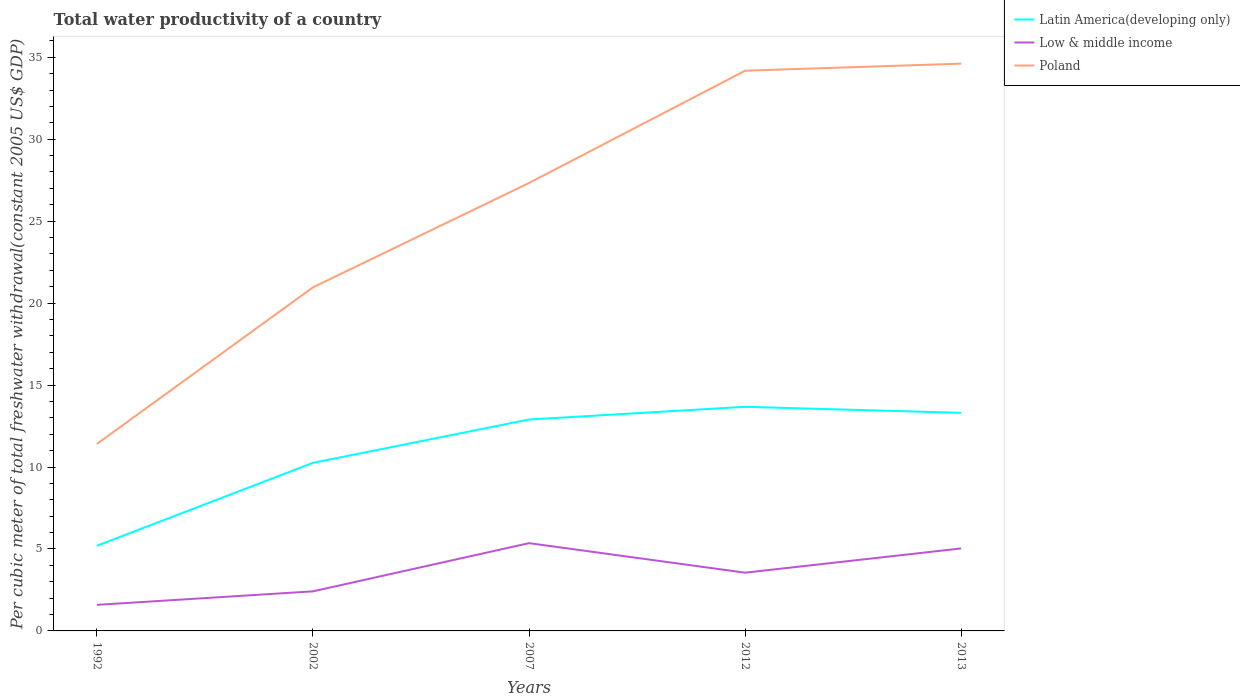How many different coloured lines are there?
Provide a short and direct response. 3. Does the line corresponding to Low & middle income intersect with the line corresponding to Poland?
Ensure brevity in your answer.  No. Across all years, what is the maximum total water productivity in Latin America(developing only)?
Offer a terse response. 5.19. In which year was the total water productivity in Low & middle income maximum?
Your answer should be compact. 1992. What is the total total water productivity in Poland in the graph?
Ensure brevity in your answer.  -9.55. What is the difference between the highest and the second highest total water productivity in Latin America(developing only)?
Give a very brief answer. 8.48. Is the total water productivity in Latin America(developing only) strictly greater than the total water productivity in Poland over the years?
Provide a succinct answer. Yes. How are the legend labels stacked?
Ensure brevity in your answer.  Vertical. What is the title of the graph?
Offer a terse response. Total water productivity of a country. What is the label or title of the X-axis?
Your response must be concise. Years. What is the label or title of the Y-axis?
Keep it short and to the point. Per cubic meter of total freshwater withdrawal(constant 2005 US$ GDP). What is the Per cubic meter of total freshwater withdrawal(constant 2005 US$ GDP) in Latin America(developing only) in 1992?
Your answer should be very brief. 5.19. What is the Per cubic meter of total freshwater withdrawal(constant 2005 US$ GDP) of Low & middle income in 1992?
Ensure brevity in your answer.  1.59. What is the Per cubic meter of total freshwater withdrawal(constant 2005 US$ GDP) of Poland in 1992?
Provide a short and direct response. 11.41. What is the Per cubic meter of total freshwater withdrawal(constant 2005 US$ GDP) in Latin America(developing only) in 2002?
Ensure brevity in your answer.  10.26. What is the Per cubic meter of total freshwater withdrawal(constant 2005 US$ GDP) in Low & middle income in 2002?
Give a very brief answer. 2.41. What is the Per cubic meter of total freshwater withdrawal(constant 2005 US$ GDP) of Poland in 2002?
Provide a short and direct response. 20.96. What is the Per cubic meter of total freshwater withdrawal(constant 2005 US$ GDP) of Latin America(developing only) in 2007?
Ensure brevity in your answer.  12.9. What is the Per cubic meter of total freshwater withdrawal(constant 2005 US$ GDP) in Low & middle income in 2007?
Your answer should be very brief. 5.35. What is the Per cubic meter of total freshwater withdrawal(constant 2005 US$ GDP) of Poland in 2007?
Keep it short and to the point. 27.33. What is the Per cubic meter of total freshwater withdrawal(constant 2005 US$ GDP) of Latin America(developing only) in 2012?
Your answer should be very brief. 13.67. What is the Per cubic meter of total freshwater withdrawal(constant 2005 US$ GDP) of Low & middle income in 2012?
Offer a very short reply. 3.55. What is the Per cubic meter of total freshwater withdrawal(constant 2005 US$ GDP) of Poland in 2012?
Keep it short and to the point. 34.18. What is the Per cubic meter of total freshwater withdrawal(constant 2005 US$ GDP) in Latin America(developing only) in 2013?
Your response must be concise. 13.31. What is the Per cubic meter of total freshwater withdrawal(constant 2005 US$ GDP) of Low & middle income in 2013?
Provide a succinct answer. 5.03. What is the Per cubic meter of total freshwater withdrawal(constant 2005 US$ GDP) of Poland in 2013?
Your response must be concise. 34.61. Across all years, what is the maximum Per cubic meter of total freshwater withdrawal(constant 2005 US$ GDP) of Latin America(developing only)?
Offer a very short reply. 13.67. Across all years, what is the maximum Per cubic meter of total freshwater withdrawal(constant 2005 US$ GDP) in Low & middle income?
Your answer should be compact. 5.35. Across all years, what is the maximum Per cubic meter of total freshwater withdrawal(constant 2005 US$ GDP) in Poland?
Your response must be concise. 34.61. Across all years, what is the minimum Per cubic meter of total freshwater withdrawal(constant 2005 US$ GDP) of Latin America(developing only)?
Make the answer very short. 5.19. Across all years, what is the minimum Per cubic meter of total freshwater withdrawal(constant 2005 US$ GDP) in Low & middle income?
Offer a terse response. 1.59. Across all years, what is the minimum Per cubic meter of total freshwater withdrawal(constant 2005 US$ GDP) in Poland?
Make the answer very short. 11.41. What is the total Per cubic meter of total freshwater withdrawal(constant 2005 US$ GDP) of Latin America(developing only) in the graph?
Provide a short and direct response. 55.33. What is the total Per cubic meter of total freshwater withdrawal(constant 2005 US$ GDP) of Low & middle income in the graph?
Keep it short and to the point. 17.95. What is the total Per cubic meter of total freshwater withdrawal(constant 2005 US$ GDP) in Poland in the graph?
Provide a succinct answer. 128.49. What is the difference between the Per cubic meter of total freshwater withdrawal(constant 2005 US$ GDP) of Latin America(developing only) in 1992 and that in 2002?
Your response must be concise. -5.06. What is the difference between the Per cubic meter of total freshwater withdrawal(constant 2005 US$ GDP) in Low & middle income in 1992 and that in 2002?
Provide a succinct answer. -0.82. What is the difference between the Per cubic meter of total freshwater withdrawal(constant 2005 US$ GDP) of Poland in 1992 and that in 2002?
Provide a short and direct response. -9.55. What is the difference between the Per cubic meter of total freshwater withdrawal(constant 2005 US$ GDP) in Latin America(developing only) in 1992 and that in 2007?
Your answer should be compact. -7.7. What is the difference between the Per cubic meter of total freshwater withdrawal(constant 2005 US$ GDP) of Low & middle income in 1992 and that in 2007?
Keep it short and to the point. -3.76. What is the difference between the Per cubic meter of total freshwater withdrawal(constant 2005 US$ GDP) of Poland in 1992 and that in 2007?
Offer a very short reply. -15.92. What is the difference between the Per cubic meter of total freshwater withdrawal(constant 2005 US$ GDP) of Latin America(developing only) in 1992 and that in 2012?
Your response must be concise. -8.48. What is the difference between the Per cubic meter of total freshwater withdrawal(constant 2005 US$ GDP) of Low & middle income in 1992 and that in 2012?
Your answer should be very brief. -1.96. What is the difference between the Per cubic meter of total freshwater withdrawal(constant 2005 US$ GDP) of Poland in 1992 and that in 2012?
Your answer should be compact. -22.77. What is the difference between the Per cubic meter of total freshwater withdrawal(constant 2005 US$ GDP) of Latin America(developing only) in 1992 and that in 2013?
Offer a terse response. -8.11. What is the difference between the Per cubic meter of total freshwater withdrawal(constant 2005 US$ GDP) of Low & middle income in 1992 and that in 2013?
Make the answer very short. -3.44. What is the difference between the Per cubic meter of total freshwater withdrawal(constant 2005 US$ GDP) of Poland in 1992 and that in 2013?
Your answer should be very brief. -23.2. What is the difference between the Per cubic meter of total freshwater withdrawal(constant 2005 US$ GDP) in Latin America(developing only) in 2002 and that in 2007?
Provide a short and direct response. -2.64. What is the difference between the Per cubic meter of total freshwater withdrawal(constant 2005 US$ GDP) in Low & middle income in 2002 and that in 2007?
Make the answer very short. -2.94. What is the difference between the Per cubic meter of total freshwater withdrawal(constant 2005 US$ GDP) of Poland in 2002 and that in 2007?
Provide a succinct answer. -6.37. What is the difference between the Per cubic meter of total freshwater withdrawal(constant 2005 US$ GDP) in Latin America(developing only) in 2002 and that in 2012?
Give a very brief answer. -3.42. What is the difference between the Per cubic meter of total freshwater withdrawal(constant 2005 US$ GDP) of Low & middle income in 2002 and that in 2012?
Your answer should be compact. -1.14. What is the difference between the Per cubic meter of total freshwater withdrawal(constant 2005 US$ GDP) in Poland in 2002 and that in 2012?
Offer a very short reply. -13.21. What is the difference between the Per cubic meter of total freshwater withdrawal(constant 2005 US$ GDP) in Latin America(developing only) in 2002 and that in 2013?
Keep it short and to the point. -3.05. What is the difference between the Per cubic meter of total freshwater withdrawal(constant 2005 US$ GDP) in Low & middle income in 2002 and that in 2013?
Offer a very short reply. -2.62. What is the difference between the Per cubic meter of total freshwater withdrawal(constant 2005 US$ GDP) of Poland in 2002 and that in 2013?
Keep it short and to the point. -13.65. What is the difference between the Per cubic meter of total freshwater withdrawal(constant 2005 US$ GDP) in Latin America(developing only) in 2007 and that in 2012?
Make the answer very short. -0.77. What is the difference between the Per cubic meter of total freshwater withdrawal(constant 2005 US$ GDP) of Low & middle income in 2007 and that in 2012?
Keep it short and to the point. 1.8. What is the difference between the Per cubic meter of total freshwater withdrawal(constant 2005 US$ GDP) in Poland in 2007 and that in 2012?
Keep it short and to the point. -6.85. What is the difference between the Per cubic meter of total freshwater withdrawal(constant 2005 US$ GDP) in Latin America(developing only) in 2007 and that in 2013?
Offer a terse response. -0.41. What is the difference between the Per cubic meter of total freshwater withdrawal(constant 2005 US$ GDP) of Low & middle income in 2007 and that in 2013?
Offer a terse response. 0.32. What is the difference between the Per cubic meter of total freshwater withdrawal(constant 2005 US$ GDP) in Poland in 2007 and that in 2013?
Make the answer very short. -7.28. What is the difference between the Per cubic meter of total freshwater withdrawal(constant 2005 US$ GDP) of Latin America(developing only) in 2012 and that in 2013?
Offer a terse response. 0.37. What is the difference between the Per cubic meter of total freshwater withdrawal(constant 2005 US$ GDP) of Low & middle income in 2012 and that in 2013?
Your response must be concise. -1.48. What is the difference between the Per cubic meter of total freshwater withdrawal(constant 2005 US$ GDP) of Poland in 2012 and that in 2013?
Keep it short and to the point. -0.43. What is the difference between the Per cubic meter of total freshwater withdrawal(constant 2005 US$ GDP) of Latin America(developing only) in 1992 and the Per cubic meter of total freshwater withdrawal(constant 2005 US$ GDP) of Low & middle income in 2002?
Your answer should be compact. 2.78. What is the difference between the Per cubic meter of total freshwater withdrawal(constant 2005 US$ GDP) of Latin America(developing only) in 1992 and the Per cubic meter of total freshwater withdrawal(constant 2005 US$ GDP) of Poland in 2002?
Keep it short and to the point. -15.77. What is the difference between the Per cubic meter of total freshwater withdrawal(constant 2005 US$ GDP) of Low & middle income in 1992 and the Per cubic meter of total freshwater withdrawal(constant 2005 US$ GDP) of Poland in 2002?
Provide a short and direct response. -19.37. What is the difference between the Per cubic meter of total freshwater withdrawal(constant 2005 US$ GDP) in Latin America(developing only) in 1992 and the Per cubic meter of total freshwater withdrawal(constant 2005 US$ GDP) in Low & middle income in 2007?
Give a very brief answer. -0.16. What is the difference between the Per cubic meter of total freshwater withdrawal(constant 2005 US$ GDP) in Latin America(developing only) in 1992 and the Per cubic meter of total freshwater withdrawal(constant 2005 US$ GDP) in Poland in 2007?
Provide a short and direct response. -22.13. What is the difference between the Per cubic meter of total freshwater withdrawal(constant 2005 US$ GDP) in Low & middle income in 1992 and the Per cubic meter of total freshwater withdrawal(constant 2005 US$ GDP) in Poland in 2007?
Ensure brevity in your answer.  -25.74. What is the difference between the Per cubic meter of total freshwater withdrawal(constant 2005 US$ GDP) in Latin America(developing only) in 1992 and the Per cubic meter of total freshwater withdrawal(constant 2005 US$ GDP) in Low & middle income in 2012?
Provide a short and direct response. 1.64. What is the difference between the Per cubic meter of total freshwater withdrawal(constant 2005 US$ GDP) of Latin America(developing only) in 1992 and the Per cubic meter of total freshwater withdrawal(constant 2005 US$ GDP) of Poland in 2012?
Offer a very short reply. -28.98. What is the difference between the Per cubic meter of total freshwater withdrawal(constant 2005 US$ GDP) in Low & middle income in 1992 and the Per cubic meter of total freshwater withdrawal(constant 2005 US$ GDP) in Poland in 2012?
Provide a short and direct response. -32.59. What is the difference between the Per cubic meter of total freshwater withdrawal(constant 2005 US$ GDP) in Latin America(developing only) in 1992 and the Per cubic meter of total freshwater withdrawal(constant 2005 US$ GDP) in Low & middle income in 2013?
Your answer should be compact. 0.16. What is the difference between the Per cubic meter of total freshwater withdrawal(constant 2005 US$ GDP) in Latin America(developing only) in 1992 and the Per cubic meter of total freshwater withdrawal(constant 2005 US$ GDP) in Poland in 2013?
Your answer should be compact. -29.42. What is the difference between the Per cubic meter of total freshwater withdrawal(constant 2005 US$ GDP) of Low & middle income in 1992 and the Per cubic meter of total freshwater withdrawal(constant 2005 US$ GDP) of Poland in 2013?
Ensure brevity in your answer.  -33.02. What is the difference between the Per cubic meter of total freshwater withdrawal(constant 2005 US$ GDP) of Latin America(developing only) in 2002 and the Per cubic meter of total freshwater withdrawal(constant 2005 US$ GDP) of Low & middle income in 2007?
Make the answer very short. 4.9. What is the difference between the Per cubic meter of total freshwater withdrawal(constant 2005 US$ GDP) in Latin America(developing only) in 2002 and the Per cubic meter of total freshwater withdrawal(constant 2005 US$ GDP) in Poland in 2007?
Make the answer very short. -17.07. What is the difference between the Per cubic meter of total freshwater withdrawal(constant 2005 US$ GDP) in Low & middle income in 2002 and the Per cubic meter of total freshwater withdrawal(constant 2005 US$ GDP) in Poland in 2007?
Ensure brevity in your answer.  -24.92. What is the difference between the Per cubic meter of total freshwater withdrawal(constant 2005 US$ GDP) of Latin America(developing only) in 2002 and the Per cubic meter of total freshwater withdrawal(constant 2005 US$ GDP) of Low & middle income in 2012?
Give a very brief answer. 6.7. What is the difference between the Per cubic meter of total freshwater withdrawal(constant 2005 US$ GDP) in Latin America(developing only) in 2002 and the Per cubic meter of total freshwater withdrawal(constant 2005 US$ GDP) in Poland in 2012?
Offer a very short reply. -23.92. What is the difference between the Per cubic meter of total freshwater withdrawal(constant 2005 US$ GDP) of Low & middle income in 2002 and the Per cubic meter of total freshwater withdrawal(constant 2005 US$ GDP) of Poland in 2012?
Offer a terse response. -31.76. What is the difference between the Per cubic meter of total freshwater withdrawal(constant 2005 US$ GDP) of Latin America(developing only) in 2002 and the Per cubic meter of total freshwater withdrawal(constant 2005 US$ GDP) of Low & middle income in 2013?
Offer a terse response. 5.22. What is the difference between the Per cubic meter of total freshwater withdrawal(constant 2005 US$ GDP) of Latin America(developing only) in 2002 and the Per cubic meter of total freshwater withdrawal(constant 2005 US$ GDP) of Poland in 2013?
Give a very brief answer. -24.36. What is the difference between the Per cubic meter of total freshwater withdrawal(constant 2005 US$ GDP) in Low & middle income in 2002 and the Per cubic meter of total freshwater withdrawal(constant 2005 US$ GDP) in Poland in 2013?
Provide a short and direct response. -32.2. What is the difference between the Per cubic meter of total freshwater withdrawal(constant 2005 US$ GDP) of Latin America(developing only) in 2007 and the Per cubic meter of total freshwater withdrawal(constant 2005 US$ GDP) of Low & middle income in 2012?
Offer a very short reply. 9.35. What is the difference between the Per cubic meter of total freshwater withdrawal(constant 2005 US$ GDP) of Latin America(developing only) in 2007 and the Per cubic meter of total freshwater withdrawal(constant 2005 US$ GDP) of Poland in 2012?
Your answer should be very brief. -21.28. What is the difference between the Per cubic meter of total freshwater withdrawal(constant 2005 US$ GDP) of Low & middle income in 2007 and the Per cubic meter of total freshwater withdrawal(constant 2005 US$ GDP) of Poland in 2012?
Your answer should be very brief. -28.82. What is the difference between the Per cubic meter of total freshwater withdrawal(constant 2005 US$ GDP) of Latin America(developing only) in 2007 and the Per cubic meter of total freshwater withdrawal(constant 2005 US$ GDP) of Low & middle income in 2013?
Your answer should be very brief. 7.87. What is the difference between the Per cubic meter of total freshwater withdrawal(constant 2005 US$ GDP) in Latin America(developing only) in 2007 and the Per cubic meter of total freshwater withdrawal(constant 2005 US$ GDP) in Poland in 2013?
Your response must be concise. -21.71. What is the difference between the Per cubic meter of total freshwater withdrawal(constant 2005 US$ GDP) of Low & middle income in 2007 and the Per cubic meter of total freshwater withdrawal(constant 2005 US$ GDP) of Poland in 2013?
Provide a short and direct response. -29.26. What is the difference between the Per cubic meter of total freshwater withdrawal(constant 2005 US$ GDP) of Latin America(developing only) in 2012 and the Per cubic meter of total freshwater withdrawal(constant 2005 US$ GDP) of Low & middle income in 2013?
Ensure brevity in your answer.  8.64. What is the difference between the Per cubic meter of total freshwater withdrawal(constant 2005 US$ GDP) of Latin America(developing only) in 2012 and the Per cubic meter of total freshwater withdrawal(constant 2005 US$ GDP) of Poland in 2013?
Keep it short and to the point. -20.94. What is the difference between the Per cubic meter of total freshwater withdrawal(constant 2005 US$ GDP) of Low & middle income in 2012 and the Per cubic meter of total freshwater withdrawal(constant 2005 US$ GDP) of Poland in 2013?
Your answer should be compact. -31.06. What is the average Per cubic meter of total freshwater withdrawal(constant 2005 US$ GDP) of Latin America(developing only) per year?
Provide a short and direct response. 11.07. What is the average Per cubic meter of total freshwater withdrawal(constant 2005 US$ GDP) in Low & middle income per year?
Provide a succinct answer. 3.59. What is the average Per cubic meter of total freshwater withdrawal(constant 2005 US$ GDP) of Poland per year?
Give a very brief answer. 25.7. In the year 1992, what is the difference between the Per cubic meter of total freshwater withdrawal(constant 2005 US$ GDP) in Latin America(developing only) and Per cubic meter of total freshwater withdrawal(constant 2005 US$ GDP) in Low & middle income?
Your response must be concise. 3.6. In the year 1992, what is the difference between the Per cubic meter of total freshwater withdrawal(constant 2005 US$ GDP) of Latin America(developing only) and Per cubic meter of total freshwater withdrawal(constant 2005 US$ GDP) of Poland?
Make the answer very short. -6.21. In the year 1992, what is the difference between the Per cubic meter of total freshwater withdrawal(constant 2005 US$ GDP) in Low & middle income and Per cubic meter of total freshwater withdrawal(constant 2005 US$ GDP) in Poland?
Offer a very short reply. -9.82. In the year 2002, what is the difference between the Per cubic meter of total freshwater withdrawal(constant 2005 US$ GDP) of Latin America(developing only) and Per cubic meter of total freshwater withdrawal(constant 2005 US$ GDP) of Low & middle income?
Offer a very short reply. 7.84. In the year 2002, what is the difference between the Per cubic meter of total freshwater withdrawal(constant 2005 US$ GDP) in Latin America(developing only) and Per cubic meter of total freshwater withdrawal(constant 2005 US$ GDP) in Poland?
Provide a short and direct response. -10.71. In the year 2002, what is the difference between the Per cubic meter of total freshwater withdrawal(constant 2005 US$ GDP) of Low & middle income and Per cubic meter of total freshwater withdrawal(constant 2005 US$ GDP) of Poland?
Ensure brevity in your answer.  -18.55. In the year 2007, what is the difference between the Per cubic meter of total freshwater withdrawal(constant 2005 US$ GDP) in Latin America(developing only) and Per cubic meter of total freshwater withdrawal(constant 2005 US$ GDP) in Low & middle income?
Provide a succinct answer. 7.54. In the year 2007, what is the difference between the Per cubic meter of total freshwater withdrawal(constant 2005 US$ GDP) of Latin America(developing only) and Per cubic meter of total freshwater withdrawal(constant 2005 US$ GDP) of Poland?
Make the answer very short. -14.43. In the year 2007, what is the difference between the Per cubic meter of total freshwater withdrawal(constant 2005 US$ GDP) of Low & middle income and Per cubic meter of total freshwater withdrawal(constant 2005 US$ GDP) of Poland?
Ensure brevity in your answer.  -21.98. In the year 2012, what is the difference between the Per cubic meter of total freshwater withdrawal(constant 2005 US$ GDP) in Latin America(developing only) and Per cubic meter of total freshwater withdrawal(constant 2005 US$ GDP) in Low & middle income?
Keep it short and to the point. 10.12. In the year 2012, what is the difference between the Per cubic meter of total freshwater withdrawal(constant 2005 US$ GDP) in Latin America(developing only) and Per cubic meter of total freshwater withdrawal(constant 2005 US$ GDP) in Poland?
Provide a succinct answer. -20.51. In the year 2012, what is the difference between the Per cubic meter of total freshwater withdrawal(constant 2005 US$ GDP) in Low & middle income and Per cubic meter of total freshwater withdrawal(constant 2005 US$ GDP) in Poland?
Your response must be concise. -30.62. In the year 2013, what is the difference between the Per cubic meter of total freshwater withdrawal(constant 2005 US$ GDP) of Latin America(developing only) and Per cubic meter of total freshwater withdrawal(constant 2005 US$ GDP) of Low & middle income?
Your answer should be very brief. 8.27. In the year 2013, what is the difference between the Per cubic meter of total freshwater withdrawal(constant 2005 US$ GDP) of Latin America(developing only) and Per cubic meter of total freshwater withdrawal(constant 2005 US$ GDP) of Poland?
Your answer should be very brief. -21.3. In the year 2013, what is the difference between the Per cubic meter of total freshwater withdrawal(constant 2005 US$ GDP) in Low & middle income and Per cubic meter of total freshwater withdrawal(constant 2005 US$ GDP) in Poland?
Give a very brief answer. -29.58. What is the ratio of the Per cubic meter of total freshwater withdrawal(constant 2005 US$ GDP) of Latin America(developing only) in 1992 to that in 2002?
Keep it short and to the point. 0.51. What is the ratio of the Per cubic meter of total freshwater withdrawal(constant 2005 US$ GDP) in Low & middle income in 1992 to that in 2002?
Provide a succinct answer. 0.66. What is the ratio of the Per cubic meter of total freshwater withdrawal(constant 2005 US$ GDP) of Poland in 1992 to that in 2002?
Ensure brevity in your answer.  0.54. What is the ratio of the Per cubic meter of total freshwater withdrawal(constant 2005 US$ GDP) of Latin America(developing only) in 1992 to that in 2007?
Make the answer very short. 0.4. What is the ratio of the Per cubic meter of total freshwater withdrawal(constant 2005 US$ GDP) in Low & middle income in 1992 to that in 2007?
Make the answer very short. 0.3. What is the ratio of the Per cubic meter of total freshwater withdrawal(constant 2005 US$ GDP) in Poland in 1992 to that in 2007?
Ensure brevity in your answer.  0.42. What is the ratio of the Per cubic meter of total freshwater withdrawal(constant 2005 US$ GDP) in Latin America(developing only) in 1992 to that in 2012?
Offer a very short reply. 0.38. What is the ratio of the Per cubic meter of total freshwater withdrawal(constant 2005 US$ GDP) in Low & middle income in 1992 to that in 2012?
Offer a very short reply. 0.45. What is the ratio of the Per cubic meter of total freshwater withdrawal(constant 2005 US$ GDP) in Poland in 1992 to that in 2012?
Make the answer very short. 0.33. What is the ratio of the Per cubic meter of total freshwater withdrawal(constant 2005 US$ GDP) of Latin America(developing only) in 1992 to that in 2013?
Provide a short and direct response. 0.39. What is the ratio of the Per cubic meter of total freshwater withdrawal(constant 2005 US$ GDP) of Low & middle income in 1992 to that in 2013?
Give a very brief answer. 0.32. What is the ratio of the Per cubic meter of total freshwater withdrawal(constant 2005 US$ GDP) in Poland in 1992 to that in 2013?
Offer a very short reply. 0.33. What is the ratio of the Per cubic meter of total freshwater withdrawal(constant 2005 US$ GDP) in Latin America(developing only) in 2002 to that in 2007?
Keep it short and to the point. 0.8. What is the ratio of the Per cubic meter of total freshwater withdrawal(constant 2005 US$ GDP) in Low & middle income in 2002 to that in 2007?
Give a very brief answer. 0.45. What is the ratio of the Per cubic meter of total freshwater withdrawal(constant 2005 US$ GDP) in Poland in 2002 to that in 2007?
Provide a succinct answer. 0.77. What is the ratio of the Per cubic meter of total freshwater withdrawal(constant 2005 US$ GDP) of Latin America(developing only) in 2002 to that in 2012?
Your response must be concise. 0.75. What is the ratio of the Per cubic meter of total freshwater withdrawal(constant 2005 US$ GDP) of Low & middle income in 2002 to that in 2012?
Give a very brief answer. 0.68. What is the ratio of the Per cubic meter of total freshwater withdrawal(constant 2005 US$ GDP) of Poland in 2002 to that in 2012?
Offer a very short reply. 0.61. What is the ratio of the Per cubic meter of total freshwater withdrawal(constant 2005 US$ GDP) in Latin America(developing only) in 2002 to that in 2013?
Your answer should be very brief. 0.77. What is the ratio of the Per cubic meter of total freshwater withdrawal(constant 2005 US$ GDP) of Low & middle income in 2002 to that in 2013?
Ensure brevity in your answer.  0.48. What is the ratio of the Per cubic meter of total freshwater withdrawal(constant 2005 US$ GDP) of Poland in 2002 to that in 2013?
Provide a short and direct response. 0.61. What is the ratio of the Per cubic meter of total freshwater withdrawal(constant 2005 US$ GDP) in Latin America(developing only) in 2007 to that in 2012?
Make the answer very short. 0.94. What is the ratio of the Per cubic meter of total freshwater withdrawal(constant 2005 US$ GDP) in Low & middle income in 2007 to that in 2012?
Give a very brief answer. 1.51. What is the ratio of the Per cubic meter of total freshwater withdrawal(constant 2005 US$ GDP) of Poland in 2007 to that in 2012?
Make the answer very short. 0.8. What is the ratio of the Per cubic meter of total freshwater withdrawal(constant 2005 US$ GDP) in Latin America(developing only) in 2007 to that in 2013?
Your response must be concise. 0.97. What is the ratio of the Per cubic meter of total freshwater withdrawal(constant 2005 US$ GDP) of Low & middle income in 2007 to that in 2013?
Offer a very short reply. 1.06. What is the ratio of the Per cubic meter of total freshwater withdrawal(constant 2005 US$ GDP) of Poland in 2007 to that in 2013?
Give a very brief answer. 0.79. What is the ratio of the Per cubic meter of total freshwater withdrawal(constant 2005 US$ GDP) in Latin America(developing only) in 2012 to that in 2013?
Give a very brief answer. 1.03. What is the ratio of the Per cubic meter of total freshwater withdrawal(constant 2005 US$ GDP) in Low & middle income in 2012 to that in 2013?
Give a very brief answer. 0.71. What is the ratio of the Per cubic meter of total freshwater withdrawal(constant 2005 US$ GDP) in Poland in 2012 to that in 2013?
Your response must be concise. 0.99. What is the difference between the highest and the second highest Per cubic meter of total freshwater withdrawal(constant 2005 US$ GDP) in Latin America(developing only)?
Keep it short and to the point. 0.37. What is the difference between the highest and the second highest Per cubic meter of total freshwater withdrawal(constant 2005 US$ GDP) of Low & middle income?
Your response must be concise. 0.32. What is the difference between the highest and the second highest Per cubic meter of total freshwater withdrawal(constant 2005 US$ GDP) in Poland?
Offer a terse response. 0.43. What is the difference between the highest and the lowest Per cubic meter of total freshwater withdrawal(constant 2005 US$ GDP) of Latin America(developing only)?
Your response must be concise. 8.48. What is the difference between the highest and the lowest Per cubic meter of total freshwater withdrawal(constant 2005 US$ GDP) of Low & middle income?
Offer a terse response. 3.76. What is the difference between the highest and the lowest Per cubic meter of total freshwater withdrawal(constant 2005 US$ GDP) in Poland?
Offer a terse response. 23.2. 